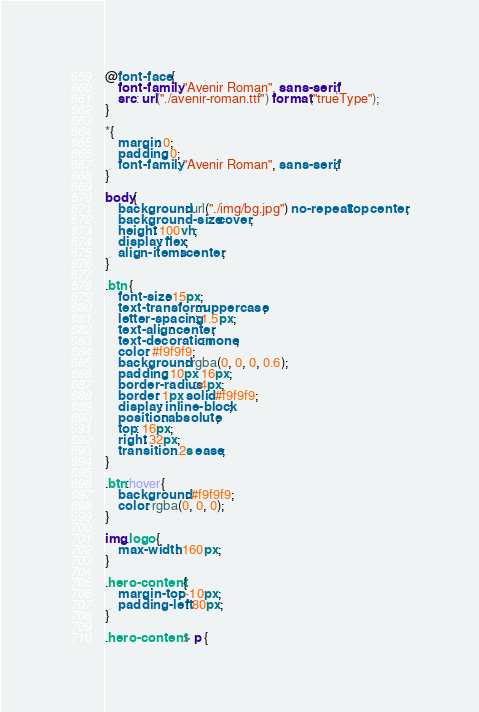<code> <loc_0><loc_0><loc_500><loc_500><_CSS_>@font-face {
    font-family: "Avenir Roman", sans-serif;
    src: url("./avenir-roman.ttf") format("trueType");
}

*{
    margin: 0;
    padding: 0;
    font-family: "Avenir Roman", sans-serif;
}

body{
    background: url("./img/bg.jpg") no-repeat top center;
    background-size: cover;
    height: 100vh;
    display: flex;
    align-items: center;
}

.btn {
    font-size: 15px;
    text-transform: uppercase;
    letter-spacing: 1.5px;
    text-align: center;
    text-decoration: none;
    color: #f9f9f9;
    background: rgba(0, 0, 0, 0.6);
    padding: 10px 16px;
    border-radius: 4px;
    border: 1px solid #f9f9f9;
    display: inline-block;
    position: absolute;
    top: 16px;
    right: 32px;
    transition: .2s ease;
}

.btn:hover{
    background: #f9f9f9;
    color: rgba(0, 0, 0);
}

img.logo {
    max-width: 160px;
}

.hero-content {
    margin-top: -10px;
    padding-left: 80px;
}

.hero-content > p {</code> 